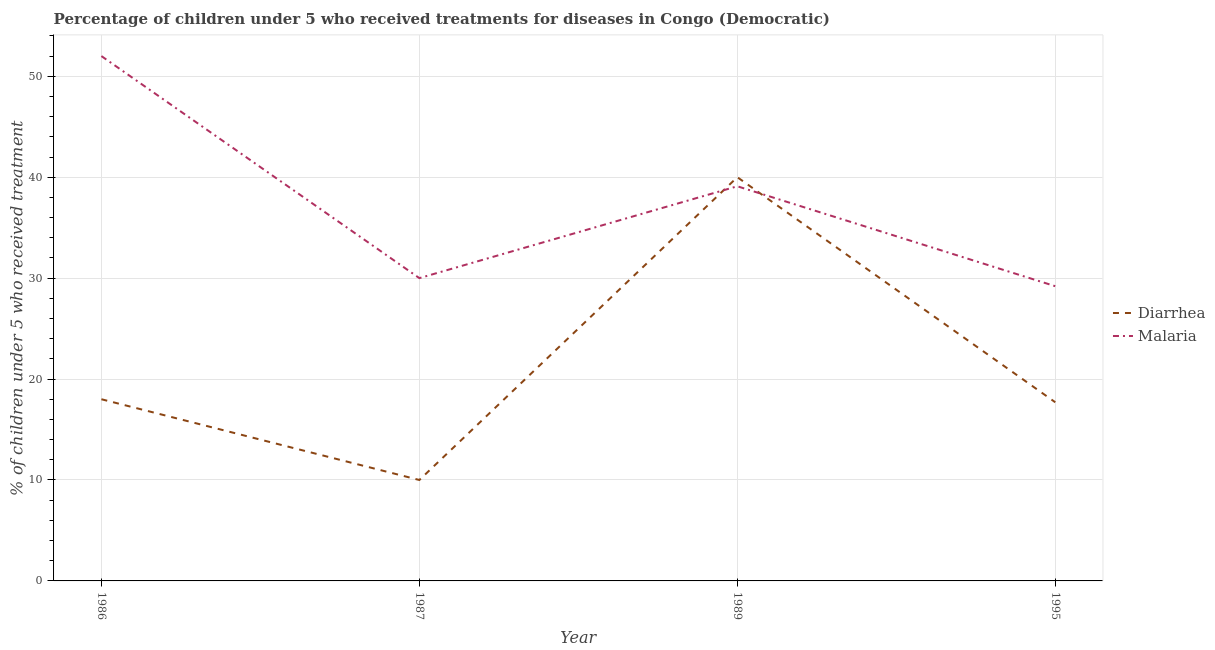Across all years, what is the maximum percentage of children who received treatment for diarrhoea?
Ensure brevity in your answer.  40. In which year was the percentage of children who received treatment for diarrhoea maximum?
Offer a very short reply. 1989. In which year was the percentage of children who received treatment for diarrhoea minimum?
Your answer should be very brief. 1987. What is the total percentage of children who received treatment for diarrhoea in the graph?
Keep it short and to the point. 85.7. What is the difference between the percentage of children who received treatment for malaria in 1986 and that in 1989?
Provide a succinct answer. 12.9. What is the difference between the percentage of children who received treatment for malaria in 1986 and the percentage of children who received treatment for diarrhoea in 1995?
Offer a terse response. 34.3. What is the average percentage of children who received treatment for diarrhoea per year?
Provide a succinct answer. 21.43. In the year 1986, what is the difference between the percentage of children who received treatment for diarrhoea and percentage of children who received treatment for malaria?
Provide a short and direct response. -34. What is the ratio of the percentage of children who received treatment for malaria in 1986 to that in 1995?
Give a very brief answer. 1.78. Is the percentage of children who received treatment for diarrhoea in 1986 less than that in 1989?
Make the answer very short. Yes. What is the difference between the highest and the second highest percentage of children who received treatment for malaria?
Offer a very short reply. 12.9. What is the difference between the highest and the lowest percentage of children who received treatment for malaria?
Offer a very short reply. 22.8. In how many years, is the percentage of children who received treatment for diarrhoea greater than the average percentage of children who received treatment for diarrhoea taken over all years?
Your answer should be compact. 1. Is the percentage of children who received treatment for malaria strictly greater than the percentage of children who received treatment for diarrhoea over the years?
Provide a short and direct response. No. What is the difference between two consecutive major ticks on the Y-axis?
Keep it short and to the point. 10. Are the values on the major ticks of Y-axis written in scientific E-notation?
Offer a very short reply. No. Where does the legend appear in the graph?
Your response must be concise. Center right. How many legend labels are there?
Offer a terse response. 2. How are the legend labels stacked?
Keep it short and to the point. Vertical. What is the title of the graph?
Offer a very short reply. Percentage of children under 5 who received treatments for diseases in Congo (Democratic). Does "Urban Population" appear as one of the legend labels in the graph?
Your response must be concise. No. What is the label or title of the X-axis?
Your answer should be very brief. Year. What is the label or title of the Y-axis?
Your answer should be compact. % of children under 5 who received treatment. What is the % of children under 5 who received treatment of Malaria in 1987?
Provide a short and direct response. 30. What is the % of children under 5 who received treatment in Diarrhea in 1989?
Your answer should be compact. 40. What is the % of children under 5 who received treatment of Malaria in 1989?
Your answer should be compact. 39.1. What is the % of children under 5 who received treatment of Diarrhea in 1995?
Provide a succinct answer. 17.7. What is the % of children under 5 who received treatment in Malaria in 1995?
Provide a short and direct response. 29.2. Across all years, what is the minimum % of children under 5 who received treatment in Diarrhea?
Make the answer very short. 10. Across all years, what is the minimum % of children under 5 who received treatment in Malaria?
Make the answer very short. 29.2. What is the total % of children under 5 who received treatment in Diarrhea in the graph?
Your answer should be very brief. 85.7. What is the total % of children under 5 who received treatment of Malaria in the graph?
Your answer should be very brief. 150.3. What is the difference between the % of children under 5 who received treatment in Malaria in 1986 and that in 1987?
Offer a terse response. 22. What is the difference between the % of children under 5 who received treatment in Malaria in 1986 and that in 1995?
Offer a very short reply. 22.8. What is the difference between the % of children under 5 who received treatment in Malaria in 1987 and that in 1989?
Your answer should be very brief. -9.1. What is the difference between the % of children under 5 who received treatment of Diarrhea in 1989 and that in 1995?
Ensure brevity in your answer.  22.3. What is the difference between the % of children under 5 who received treatment of Malaria in 1989 and that in 1995?
Provide a short and direct response. 9.9. What is the difference between the % of children under 5 who received treatment of Diarrhea in 1986 and the % of children under 5 who received treatment of Malaria in 1987?
Give a very brief answer. -12. What is the difference between the % of children under 5 who received treatment of Diarrhea in 1986 and the % of children under 5 who received treatment of Malaria in 1989?
Your answer should be very brief. -21.1. What is the difference between the % of children under 5 who received treatment in Diarrhea in 1986 and the % of children under 5 who received treatment in Malaria in 1995?
Ensure brevity in your answer.  -11.2. What is the difference between the % of children under 5 who received treatment in Diarrhea in 1987 and the % of children under 5 who received treatment in Malaria in 1989?
Make the answer very short. -29.1. What is the difference between the % of children under 5 who received treatment of Diarrhea in 1987 and the % of children under 5 who received treatment of Malaria in 1995?
Make the answer very short. -19.2. What is the average % of children under 5 who received treatment of Diarrhea per year?
Offer a terse response. 21.43. What is the average % of children under 5 who received treatment in Malaria per year?
Make the answer very short. 37.58. In the year 1986, what is the difference between the % of children under 5 who received treatment of Diarrhea and % of children under 5 who received treatment of Malaria?
Ensure brevity in your answer.  -34. What is the ratio of the % of children under 5 who received treatment in Diarrhea in 1986 to that in 1987?
Make the answer very short. 1.8. What is the ratio of the % of children under 5 who received treatment of Malaria in 1986 to that in 1987?
Your answer should be very brief. 1.73. What is the ratio of the % of children under 5 who received treatment of Diarrhea in 1986 to that in 1989?
Make the answer very short. 0.45. What is the ratio of the % of children under 5 who received treatment of Malaria in 1986 to that in 1989?
Offer a terse response. 1.33. What is the ratio of the % of children under 5 who received treatment in Diarrhea in 1986 to that in 1995?
Offer a very short reply. 1.02. What is the ratio of the % of children under 5 who received treatment of Malaria in 1986 to that in 1995?
Make the answer very short. 1.78. What is the ratio of the % of children under 5 who received treatment in Diarrhea in 1987 to that in 1989?
Provide a succinct answer. 0.25. What is the ratio of the % of children under 5 who received treatment in Malaria in 1987 to that in 1989?
Your response must be concise. 0.77. What is the ratio of the % of children under 5 who received treatment in Diarrhea in 1987 to that in 1995?
Keep it short and to the point. 0.56. What is the ratio of the % of children under 5 who received treatment of Malaria in 1987 to that in 1995?
Give a very brief answer. 1.03. What is the ratio of the % of children under 5 who received treatment of Diarrhea in 1989 to that in 1995?
Your response must be concise. 2.26. What is the ratio of the % of children under 5 who received treatment in Malaria in 1989 to that in 1995?
Provide a succinct answer. 1.34. What is the difference between the highest and the second highest % of children under 5 who received treatment in Malaria?
Offer a terse response. 12.9. What is the difference between the highest and the lowest % of children under 5 who received treatment in Malaria?
Your response must be concise. 22.8. 